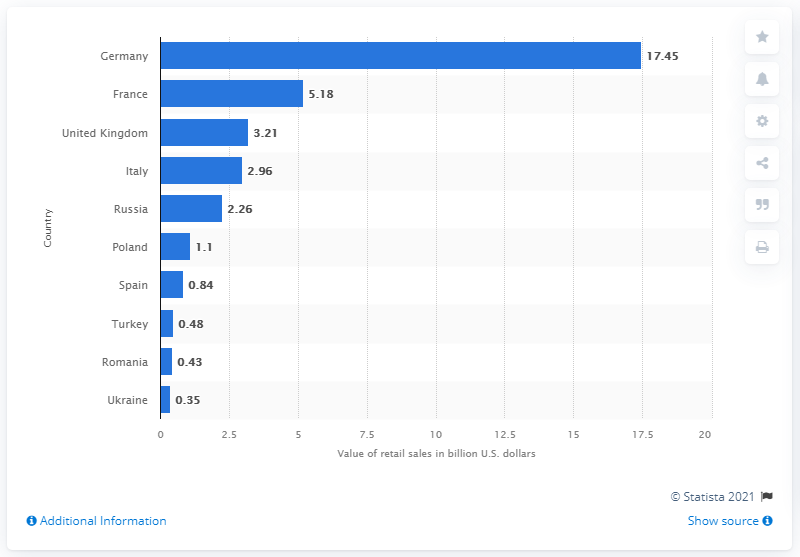Specify some key components in this picture. The direct selling market in Germany generated retail sales of approximately 17.45 billion U.S. dollars in 2019. 